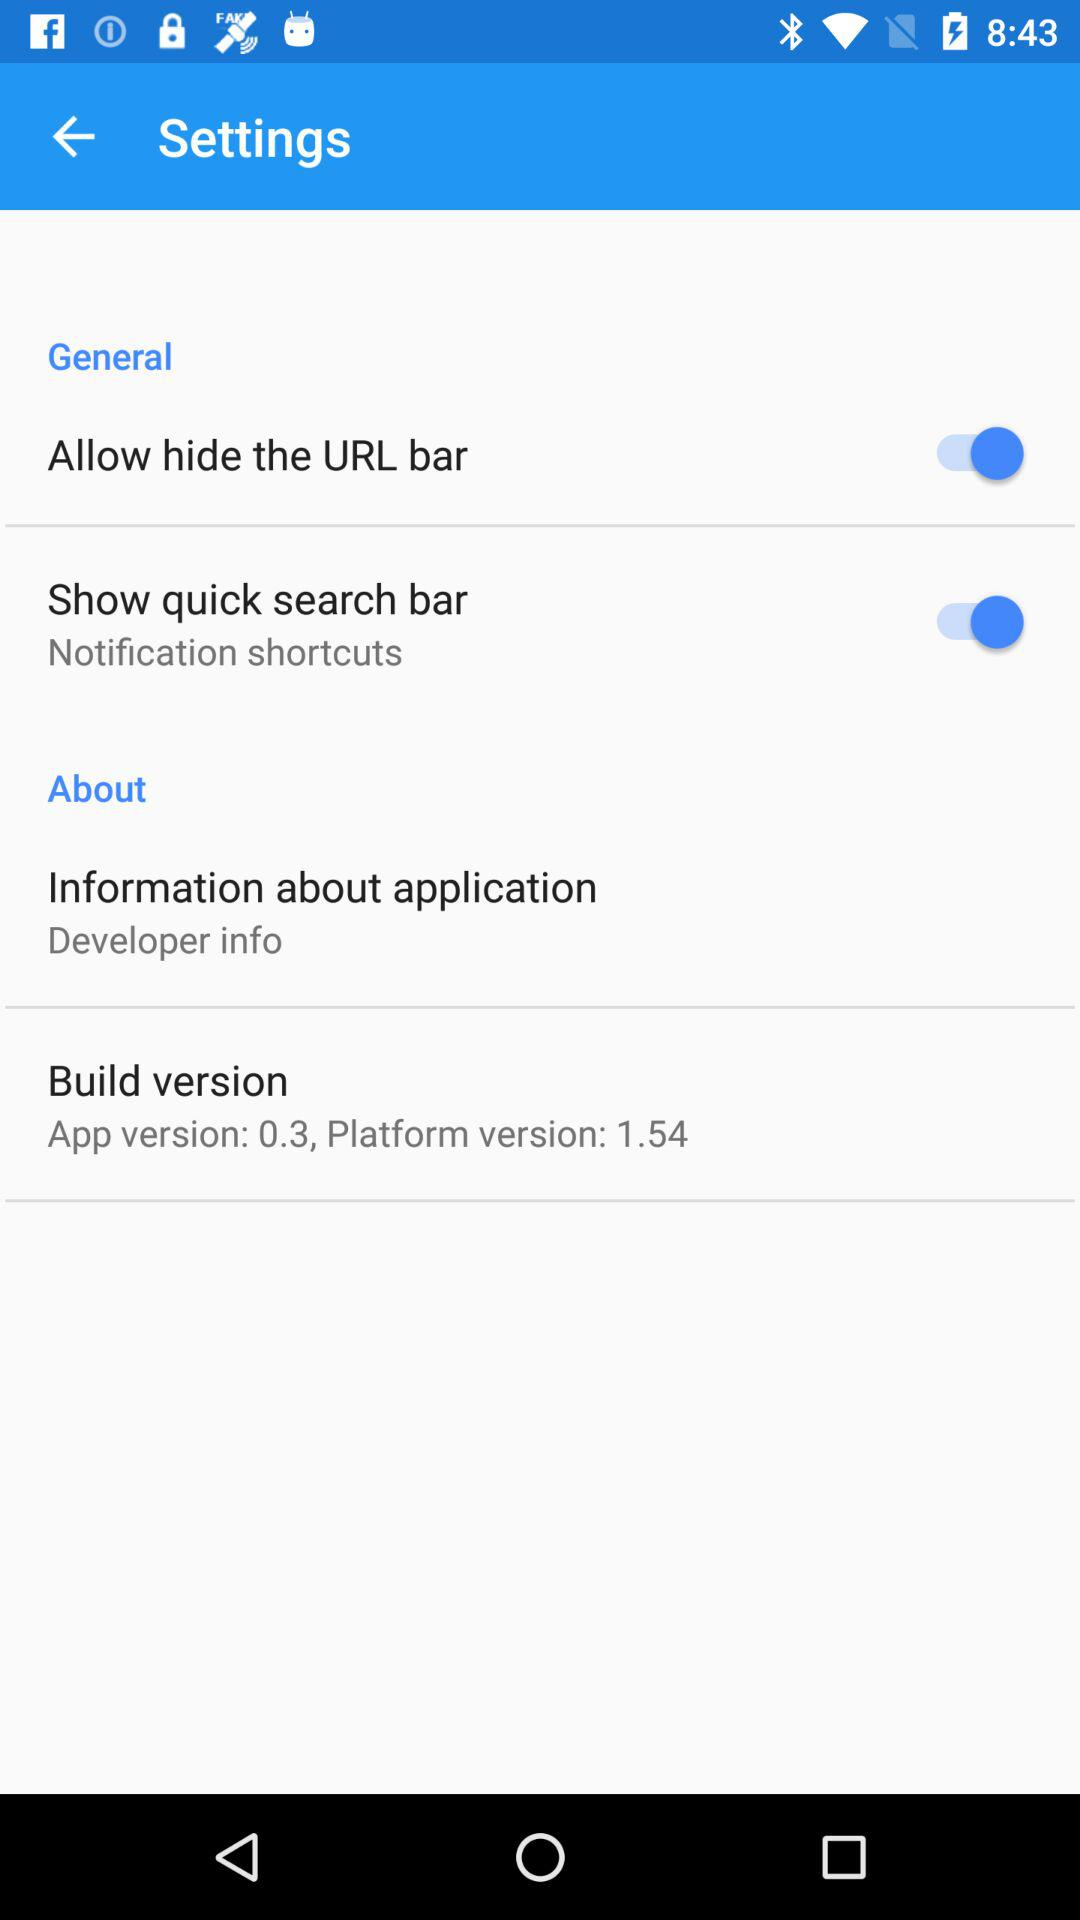What is the status of "Allow hide the URL bar"? The status of "Allow hide the URL bar" is "on". 